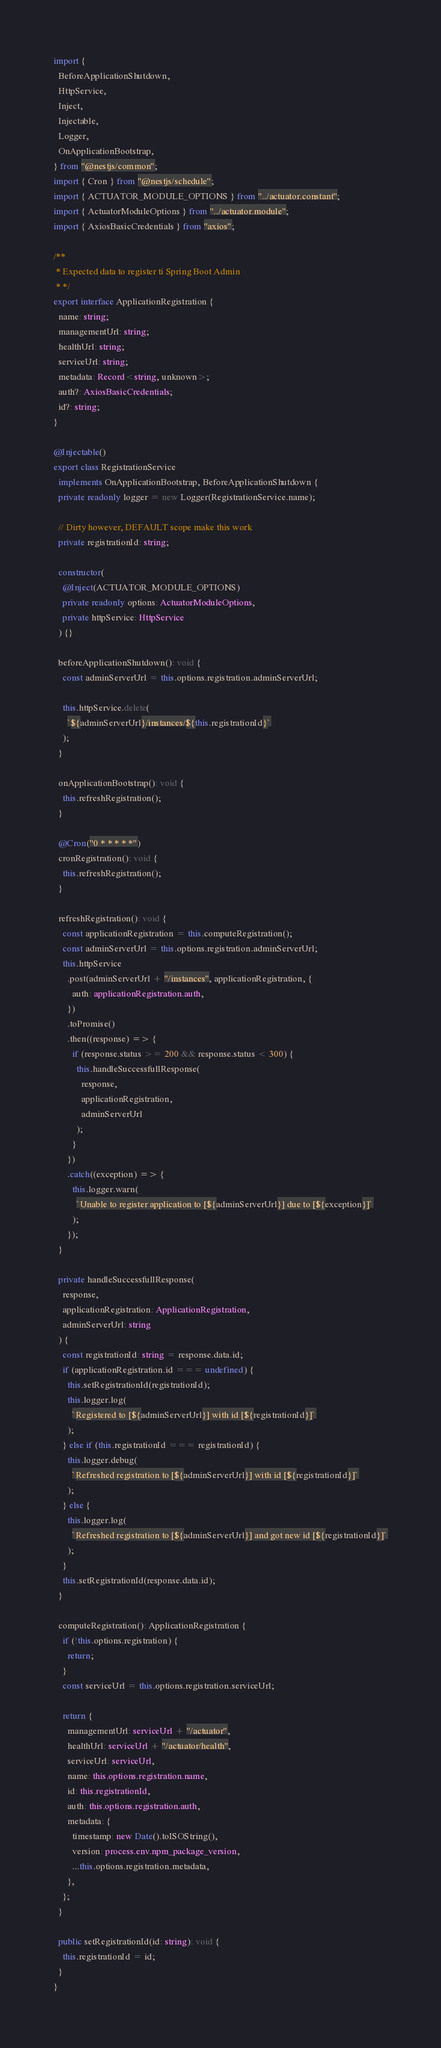Convert code to text. <code><loc_0><loc_0><loc_500><loc_500><_TypeScript_>import {
  BeforeApplicationShutdown,
  HttpService,
  Inject,
  Injectable,
  Logger,
  OnApplicationBootstrap,
} from "@nestjs/common";
import { Cron } from "@nestjs/schedule";
import { ACTUATOR_MODULE_OPTIONS } from "../actuator.constant";
import { ActuatorModuleOptions } from "../actuator.module";
import { AxiosBasicCredentials } from "axios";

/**
 * Expected data to register ti Spring Boot Admin
 * */
export interface ApplicationRegistration {
  name: string;
  managementUrl: string;
  healthUrl: string;
  serviceUrl: string;
  metadata: Record<string, unknown>;
  auth?: AxiosBasicCredentials;
  id?: string;
}

@Injectable()
export class RegistrationService
  implements OnApplicationBootstrap, BeforeApplicationShutdown {
  private readonly logger = new Logger(RegistrationService.name);

  // Dirty however, DEFAULT scope make this work
  private registrationId: string;

  constructor(
    @Inject(ACTUATOR_MODULE_OPTIONS)
    private readonly options: ActuatorModuleOptions,
    private httpService: HttpService
  ) {}

  beforeApplicationShutdown(): void {
    const adminServerUrl = this.options.registration.adminServerUrl;

    this.httpService.delete(
      `${adminServerUrl}/instances/${this.registrationId}`
    );
  }

  onApplicationBootstrap(): void {
    this.refreshRegistration();
  }

  @Cron("0 * * * * *")
  cronRegistration(): void {
    this.refreshRegistration();
  }

  refreshRegistration(): void {
    const applicationRegistration = this.computeRegistration();
    const adminServerUrl = this.options.registration.adminServerUrl;
    this.httpService
      .post(adminServerUrl + "/instances", applicationRegistration, {
        auth: applicationRegistration.auth,
      })
      .toPromise()
      .then((response) => {
        if (response.status >= 200 && response.status < 300) {
          this.handleSuccessfullResponse(
            response,
            applicationRegistration,
            adminServerUrl
          );
        }
      })
      .catch((exception) => {
        this.logger.warn(
          `Unable to register application to [${adminServerUrl}] due to [${exception}]`
        );
      });
  }

  private handleSuccessfullResponse(
    response,
    applicationRegistration: ApplicationRegistration,
    adminServerUrl: string
  ) {
    const registrationId: string = response.data.id;
    if (applicationRegistration.id === undefined) {
      this.setRegistrationId(registrationId);
      this.logger.log(
        `Registered to [${adminServerUrl}] with id [${registrationId}]`
      );
    } else if (this.registrationId === registrationId) {
      this.logger.debug(
        `Refreshed registration to [${adminServerUrl}] with id [${registrationId}]`
      );
    } else {
      this.logger.log(
        `Refreshed registration to [${adminServerUrl}] and got new id [${registrationId}]`
      );
    }
    this.setRegistrationId(response.data.id);
  }

  computeRegistration(): ApplicationRegistration {
    if (!this.options.registration) {
      return;
    }
    const serviceUrl = this.options.registration.serviceUrl;

    return {
      managementUrl: serviceUrl + "/actuator",
      healthUrl: serviceUrl + "/actuator/health",
      serviceUrl: serviceUrl,
      name: this.options.registration.name,
      id: this.registrationId,
      auth: this.options.registration.auth,
      metadata: {
        timestamp: new Date().toISOString(),
        version: process.env.npm_package_version,
        ...this.options.registration.metadata,
      },
    };
  }

  public setRegistrationId(id: string): void {
    this.registrationId = id;
  }
}
</code> 